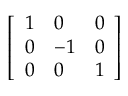<formula> <loc_0><loc_0><loc_500><loc_500>\left [ { \begin{array} { l l l } { 1 } & { 0 } & { 0 } \\ { 0 } & { - 1 } & { 0 } \\ { 0 } & { 0 } & { 1 } \end{array} } \right ]</formula> 